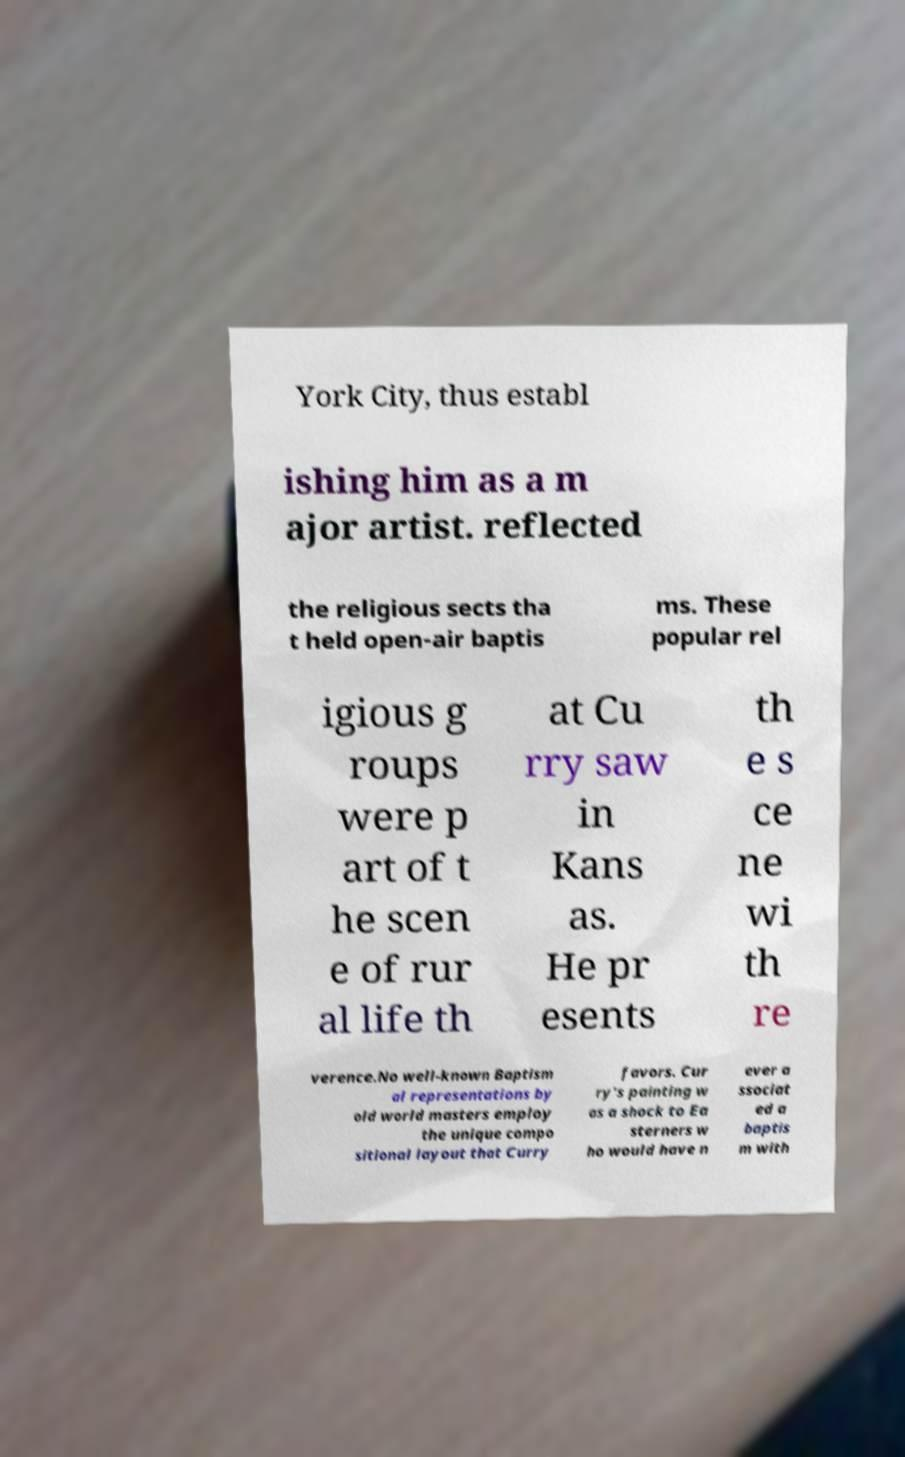I need the written content from this picture converted into text. Can you do that? York City, thus establ ishing him as a m ajor artist. reflected the religious sects tha t held open-air baptis ms. These popular rel igious g roups were p art of t he scen e of rur al life th at Cu rry saw in Kans as. He pr esents th e s ce ne wi th re verence.No well-known Baptism al representations by old world masters employ the unique compo sitional layout that Curry favors. Cur ry's painting w as a shock to Ea sterners w ho would have n ever a ssociat ed a baptis m with 